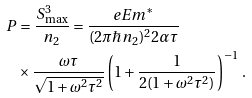Convert formula to latex. <formula><loc_0><loc_0><loc_500><loc_500>P & = \frac { S ^ { 3 } _ { \max } } { n _ { 2 } } = \frac { e E m ^ { \ast } } { ( 2 \pi \hbar { n } _ { 2 } ) ^ { 2 } 2 \alpha \tau } \\ & \times \frac { \omega \tau } { \sqrt { 1 + \omega ^ { 2 } \tau ^ { 2 } } } \left ( 1 + \frac { 1 } { 2 ( 1 + \omega ^ { 2 } \tau ^ { 2 } ) } \right ) ^ { - 1 } \, .</formula> 